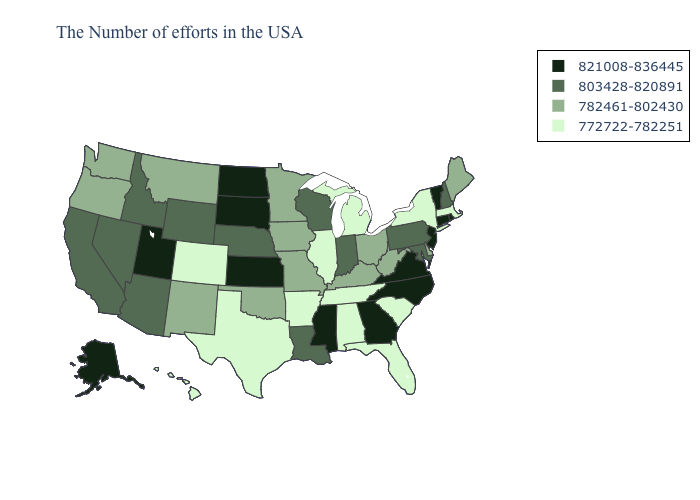How many symbols are there in the legend?
Short answer required. 4. What is the highest value in states that border Rhode Island?
Short answer required. 821008-836445. What is the value of California?
Give a very brief answer. 803428-820891. What is the highest value in the MidWest ?
Keep it brief. 821008-836445. Does Montana have the highest value in the West?
Give a very brief answer. No. Name the states that have a value in the range 821008-836445?
Keep it brief. Rhode Island, Vermont, Connecticut, New Jersey, Virginia, North Carolina, Georgia, Mississippi, Kansas, South Dakota, North Dakota, Utah, Alaska. What is the value of Oklahoma?
Short answer required. 782461-802430. Name the states that have a value in the range 782461-802430?
Keep it brief. Maine, Delaware, West Virginia, Ohio, Kentucky, Missouri, Minnesota, Iowa, Oklahoma, New Mexico, Montana, Washington, Oregon. Among the states that border Colorado , does Nebraska have the highest value?
Quick response, please. No. Among the states that border Pennsylvania , which have the lowest value?
Be succinct. New York. What is the lowest value in the USA?
Be succinct. 772722-782251. Does Alabama have the lowest value in the USA?
Write a very short answer. Yes. Which states hav the highest value in the MidWest?
Give a very brief answer. Kansas, South Dakota, North Dakota. Which states hav the highest value in the South?
Write a very short answer. Virginia, North Carolina, Georgia, Mississippi. What is the lowest value in states that border Oregon?
Answer briefly. 782461-802430. 